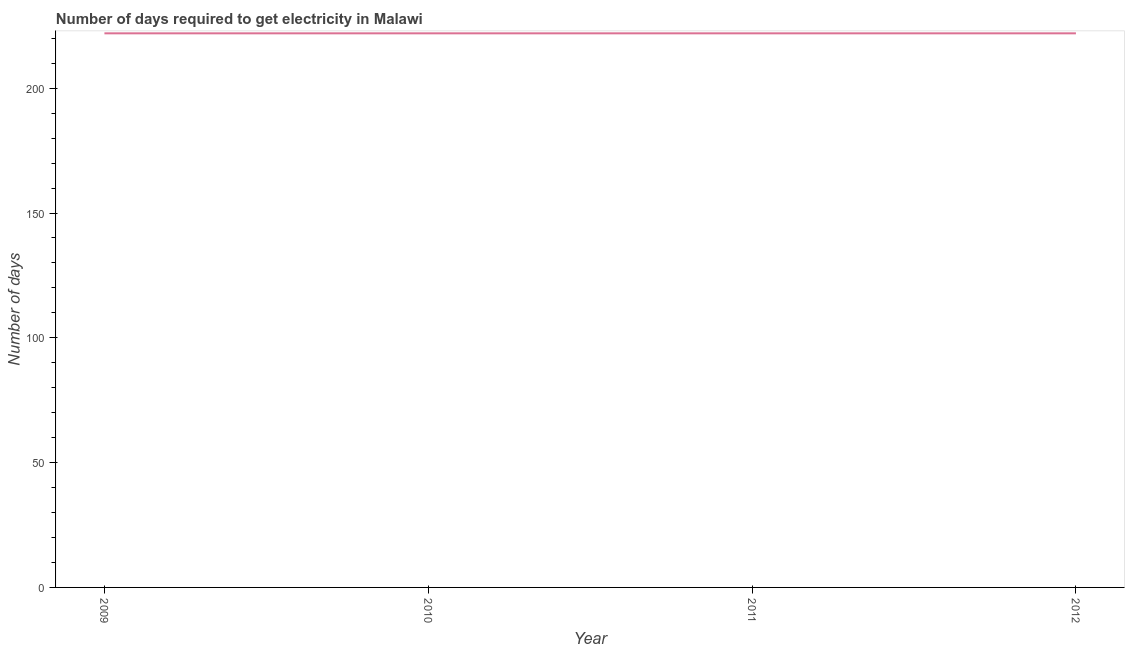What is the time to get electricity in 2009?
Your answer should be very brief. 222. Across all years, what is the maximum time to get electricity?
Keep it short and to the point. 222. Across all years, what is the minimum time to get electricity?
Your answer should be very brief. 222. In which year was the time to get electricity maximum?
Offer a very short reply. 2009. What is the sum of the time to get electricity?
Your response must be concise. 888. What is the difference between the time to get electricity in 2009 and 2010?
Ensure brevity in your answer.  0. What is the average time to get electricity per year?
Your answer should be compact. 222. What is the median time to get electricity?
Offer a terse response. 222. In how many years, is the time to get electricity greater than 150 ?
Offer a terse response. 4. Do a majority of the years between 2009 and 2012 (inclusive) have time to get electricity greater than 160 ?
Your response must be concise. Yes. What is the ratio of the time to get electricity in 2010 to that in 2012?
Make the answer very short. 1. Is the time to get electricity in 2010 less than that in 2012?
Provide a short and direct response. No. Is the difference between the time to get electricity in 2010 and 2011 greater than the difference between any two years?
Your answer should be very brief. Yes. Is the sum of the time to get electricity in 2011 and 2012 greater than the maximum time to get electricity across all years?
Give a very brief answer. Yes. Does the time to get electricity monotonically increase over the years?
Your answer should be compact. No. How many lines are there?
Your answer should be compact. 1. How many years are there in the graph?
Make the answer very short. 4. Does the graph contain grids?
Your answer should be very brief. No. What is the title of the graph?
Your answer should be compact. Number of days required to get electricity in Malawi. What is the label or title of the X-axis?
Make the answer very short. Year. What is the label or title of the Y-axis?
Give a very brief answer. Number of days. What is the Number of days in 2009?
Ensure brevity in your answer.  222. What is the Number of days of 2010?
Give a very brief answer. 222. What is the Number of days in 2011?
Provide a succinct answer. 222. What is the Number of days of 2012?
Your answer should be very brief. 222. What is the difference between the Number of days in 2009 and 2010?
Make the answer very short. 0. What is the difference between the Number of days in 2009 and 2012?
Provide a short and direct response. 0. What is the difference between the Number of days in 2010 and 2012?
Make the answer very short. 0. What is the difference between the Number of days in 2011 and 2012?
Provide a short and direct response. 0. What is the ratio of the Number of days in 2009 to that in 2011?
Give a very brief answer. 1. What is the ratio of the Number of days in 2010 to that in 2011?
Your response must be concise. 1. 